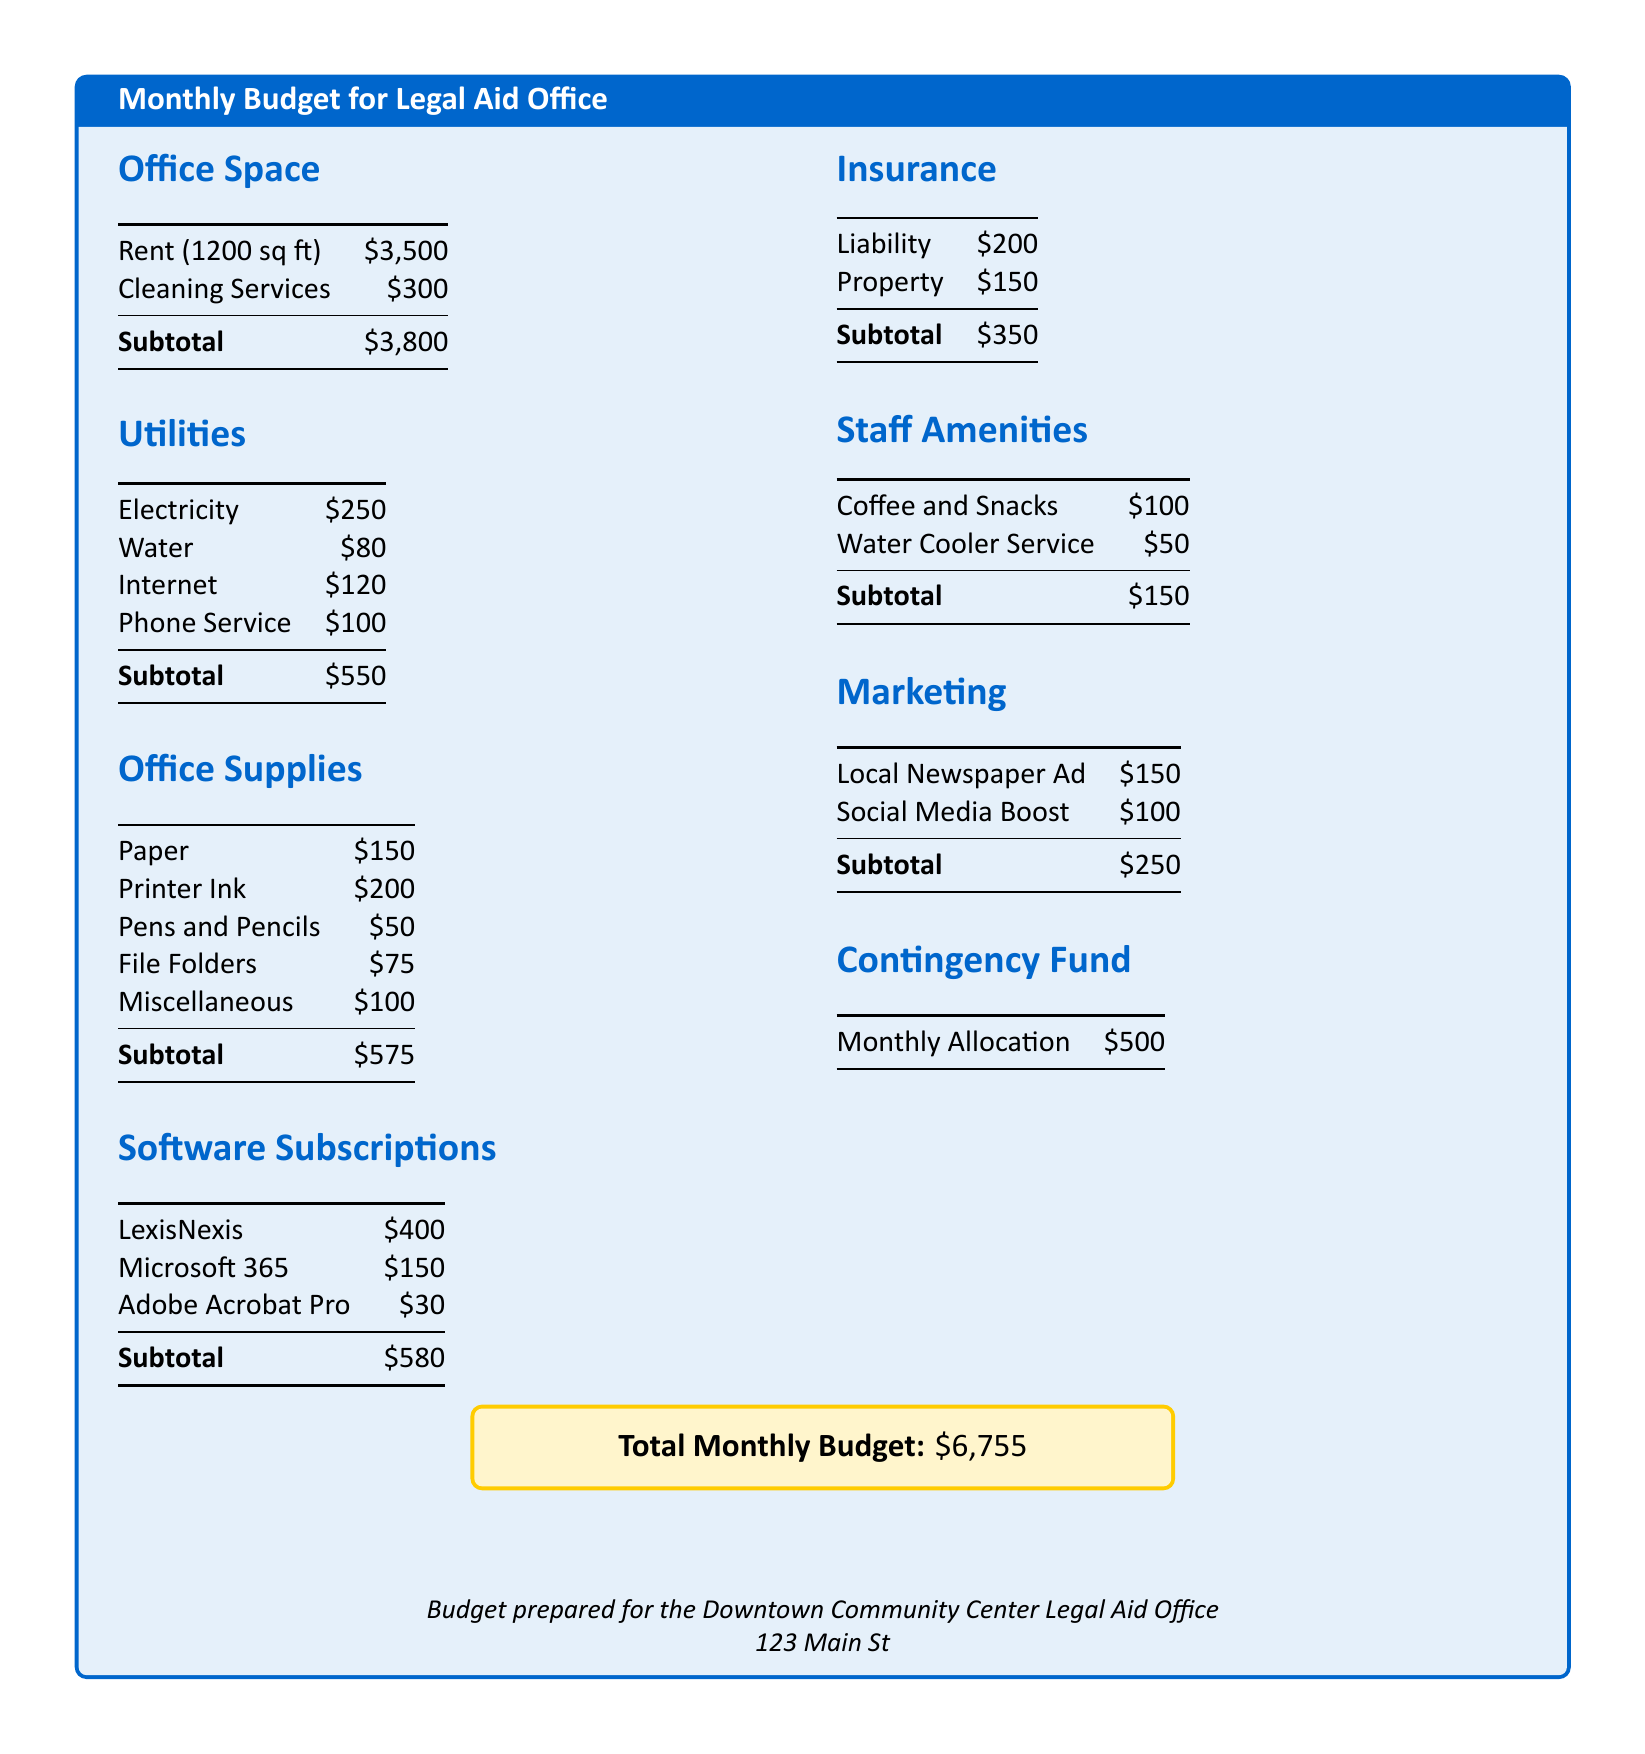What is the total monthly budget? The total monthly budget is presented clearly in the budget document, which sums up all operational expenses.
Answer: $6,755 How much is spent on rent? The rent amount is listed under the office space section of the document, specifically for 1200 sq ft.
Answer: $3,500 What is the subtotal for utilities? The subtotal for utilities is provided at the end of the utilities section, summarizing electricity, water, internet, and phone service costs.
Answer: $550 What are the office supply costs for printer ink? The cost for printer ink is itemized under the office supplies section of the budget.
Answer: $200 What is the total cost of cleaning services and rent? This requires adding cleaning services to rent, combining both figures presented in the office space section.
Answer: $3,800 How much is allocated for the contingency fund? The contingency fund is listed as a separate entry and indicates the allocation for unexpected expenses.
Answer: $500 How much is spent on marketing? The marketing section details the costs for local newspaper advertising and social media boosting.
Answer: $250 What is the subtotal for staff amenities? The staff amenities section provides a subtotal that combines the costs for coffee, snacks, and water cooler service.
Answer: $150 What is the cost of the liability insurance? The liability insurance expense is specified in the insurance section of the budget.
Answer: $200 